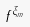<formula> <loc_0><loc_0><loc_500><loc_500>f ^ { \xi _ { m } }</formula> 